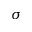Convert formula to latex. <formula><loc_0><loc_0><loc_500><loc_500>\sigma</formula> 